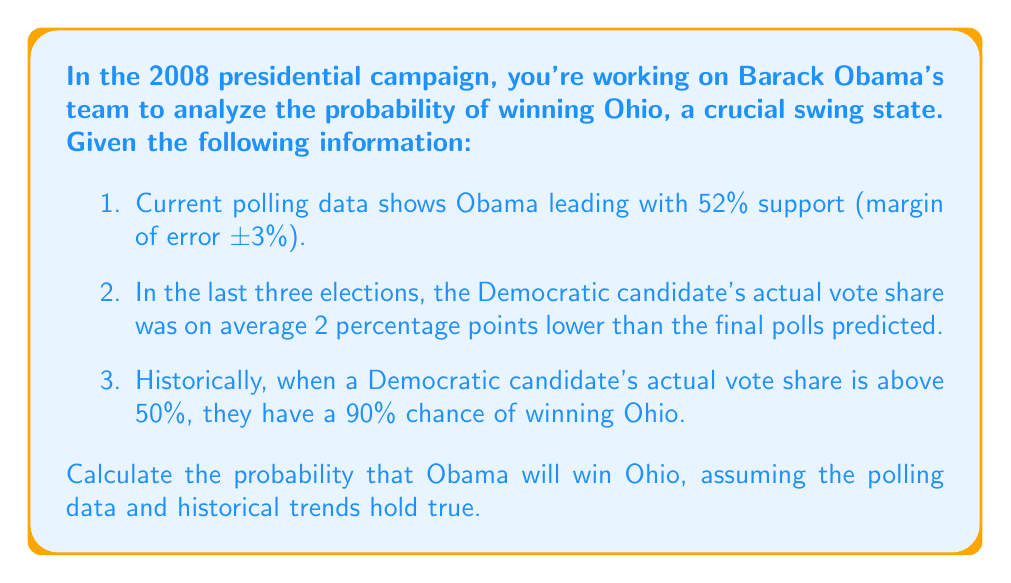Show me your answer to this math problem. Let's approach this problem step-by-step using Bayesian reasoning:

1. First, we need to estimate Obama's true support, considering both the poll and historical bias:

   $$\text{Estimated true support} = 52\% - 2\% = 50\%$$

2. Now, we need to account for the margin of error. We can model this as a normal distribution with:
   
   $$\mu = 50\%$$
   $$\sigma = 3\%$$

3. We want to find the probability that Obama's true support is above 50%. This can be calculated using the standard normal distribution:

   $$P(\text{true support} > 50\%) = P(Z > \frac{50\% - 50\%}{3\%}) = P(Z > 0) = 0.5$$

4. Now we can use Bayes' theorem to calculate the probability of winning:

   $$P(\text{Win}|\text{Support} > 50\%) = 0.90$$

   $$P(\text{Support} > 50\%) = 0.5$$

   $$P(\text{Win}) = P(\text{Win}|\text{Support} > 50\%) \cdot P(\text{Support} > 50\%) + P(\text{Win}|\text{Support} \leq 50\%) \cdot P(\text{Support} \leq 50\%)$$

5. We don't know $P(\text{Win}|\text{Support} \leq 50\%)$, but we can estimate it as $1 - P(\text{Win}|\text{Support} > 50\%) = 0.1$, assuming symmetry.

6. Plugging in the values:

   $$P(\text{Win}) = 0.90 \cdot 0.5 + 0.1 \cdot 0.5 = 0.45 + 0.05 = 0.5$$

Therefore, the probability of Obama winning Ohio is 0.5 or 50%.
Answer: The probability that Obama will win Ohio is 0.5 or 50%. 